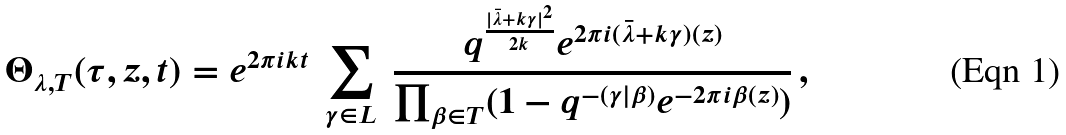<formula> <loc_0><loc_0><loc_500><loc_500>\Theta _ { \lambda , T } ( \tau , z , t ) = e ^ { 2 \pi i k t } \ \sum _ { \gamma \in L } \ \frac { q ^ { \frac { | \bar { \lambda } + k \gamma | ^ { 2 } } { 2 k } } e ^ { 2 \pi i ( \bar { \lambda } + k \gamma ) ( z ) } } { \prod _ { \beta \in T } ( 1 - q ^ { - ( \gamma | \beta ) } e ^ { - 2 \pi i \beta ( z ) } ) } \, ,</formula> 